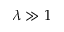<formula> <loc_0><loc_0><loc_500><loc_500>\lambda \gg 1</formula> 